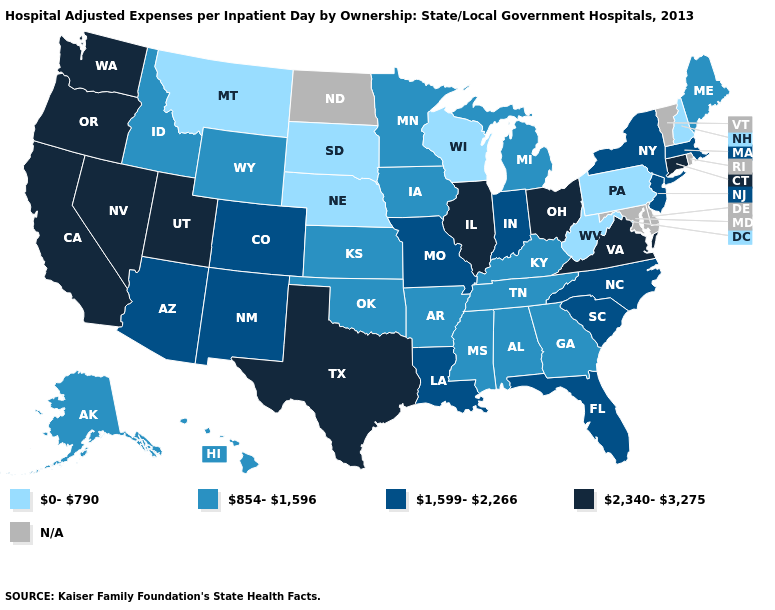Among the states that border Arkansas , which have the lowest value?
Write a very short answer. Mississippi, Oklahoma, Tennessee. Does the map have missing data?
Concise answer only. Yes. Which states hav the highest value in the West?
Keep it brief. California, Nevada, Oregon, Utah, Washington. How many symbols are there in the legend?
Be succinct. 5. Among the states that border New York , which have the highest value?
Quick response, please. Connecticut. What is the highest value in the MidWest ?
Short answer required. 2,340-3,275. Name the states that have a value in the range 1,599-2,266?
Write a very short answer. Arizona, Colorado, Florida, Indiana, Louisiana, Massachusetts, Missouri, New Jersey, New Mexico, New York, North Carolina, South Carolina. Name the states that have a value in the range 2,340-3,275?
Short answer required. California, Connecticut, Illinois, Nevada, Ohio, Oregon, Texas, Utah, Virginia, Washington. Among the states that border New Jersey , does Pennsylvania have the lowest value?
Short answer required. Yes. Name the states that have a value in the range 2,340-3,275?
Write a very short answer. California, Connecticut, Illinois, Nevada, Ohio, Oregon, Texas, Utah, Virginia, Washington. What is the value of Minnesota?
Concise answer only. 854-1,596. What is the value of Kansas?
Answer briefly. 854-1,596. What is the value of New Jersey?
Be succinct. 1,599-2,266. What is the value of Missouri?
Be succinct. 1,599-2,266. Which states have the lowest value in the USA?
Give a very brief answer. Montana, Nebraska, New Hampshire, Pennsylvania, South Dakota, West Virginia, Wisconsin. 